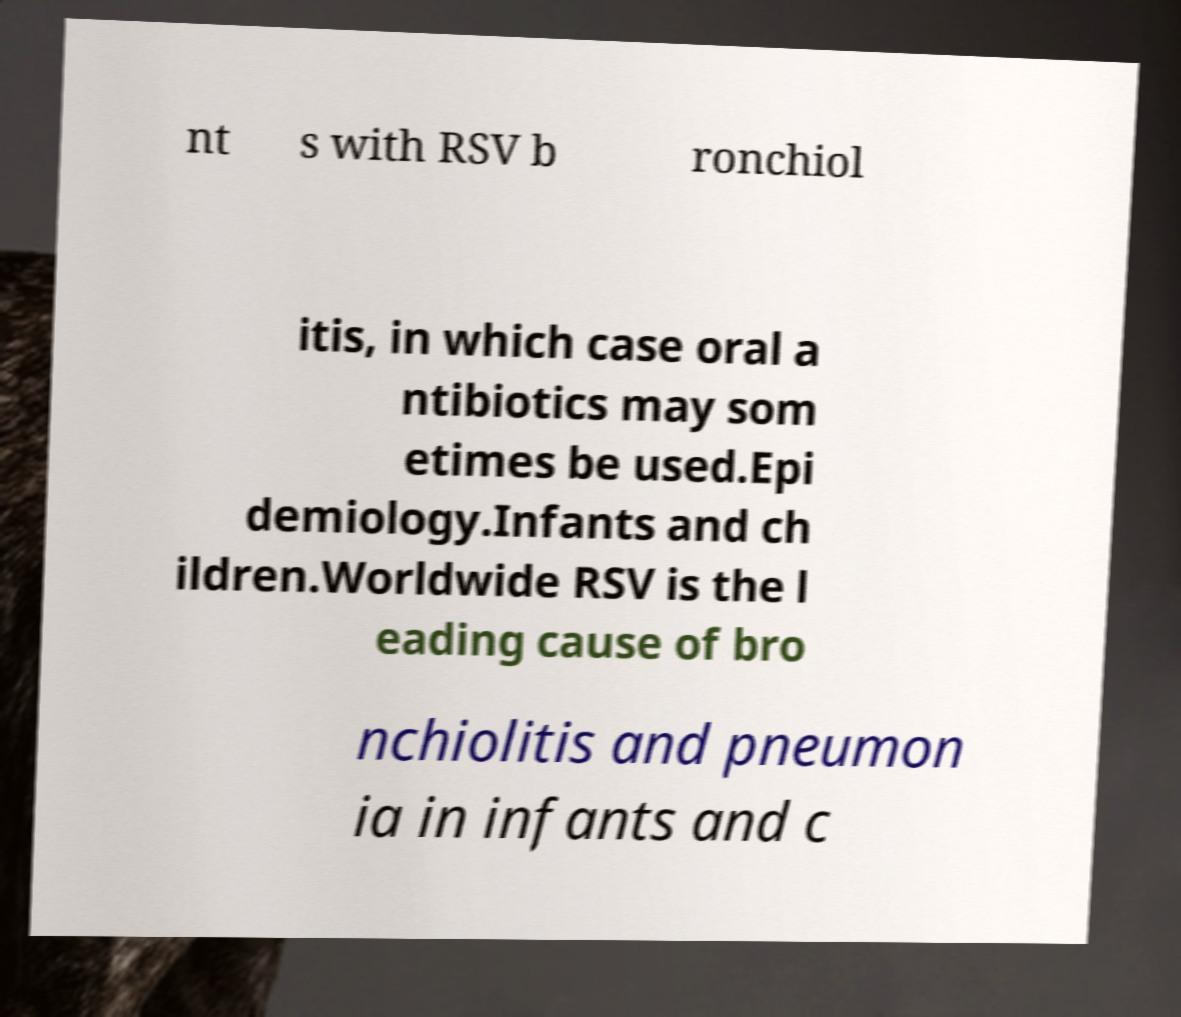Could you extract and type out the text from this image? nt s with RSV b ronchiol itis, in which case oral a ntibiotics may som etimes be used.Epi demiology.Infants and ch ildren.Worldwide RSV is the l eading cause of bro nchiolitis and pneumon ia in infants and c 